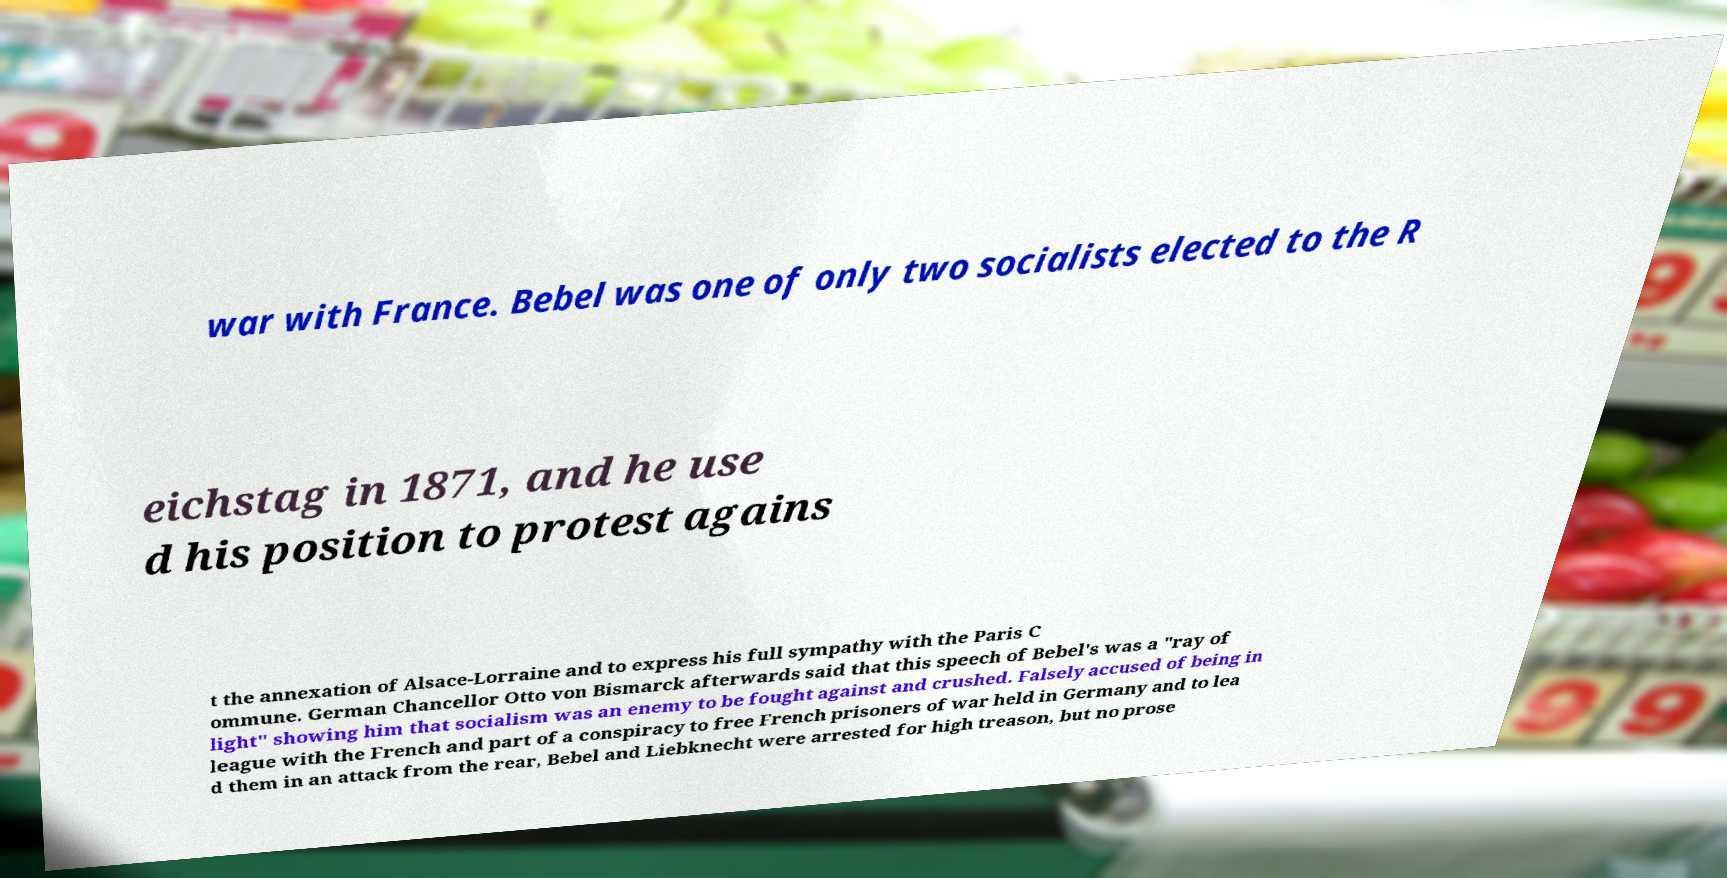For documentation purposes, I need the text within this image transcribed. Could you provide that? war with France. Bebel was one of only two socialists elected to the R eichstag in 1871, and he use d his position to protest agains t the annexation of Alsace-Lorraine and to express his full sympathy with the Paris C ommune. German Chancellor Otto von Bismarck afterwards said that this speech of Bebel's was a "ray of light" showing him that socialism was an enemy to be fought against and crushed. Falsely accused of being in league with the French and part of a conspiracy to free French prisoners of war held in Germany and to lea d them in an attack from the rear, Bebel and Liebknecht were arrested for high treason, but no prose 